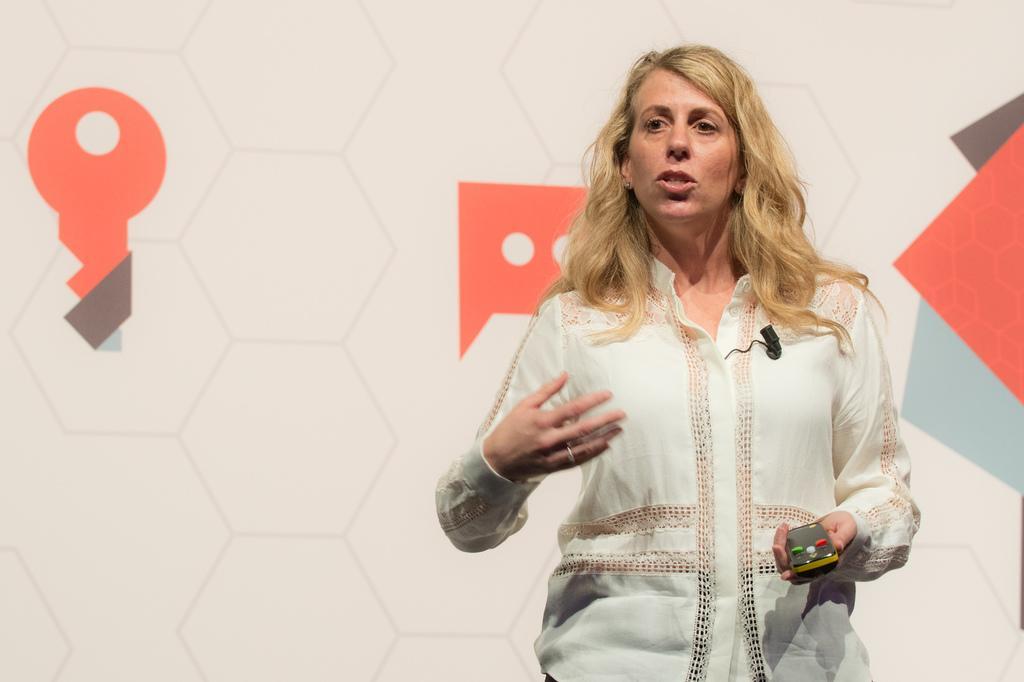Could you give a brief overview of what you see in this image? In this image there is a woman standing and speaking and holding an object in her hand. In the background there is a board with some images on it. 